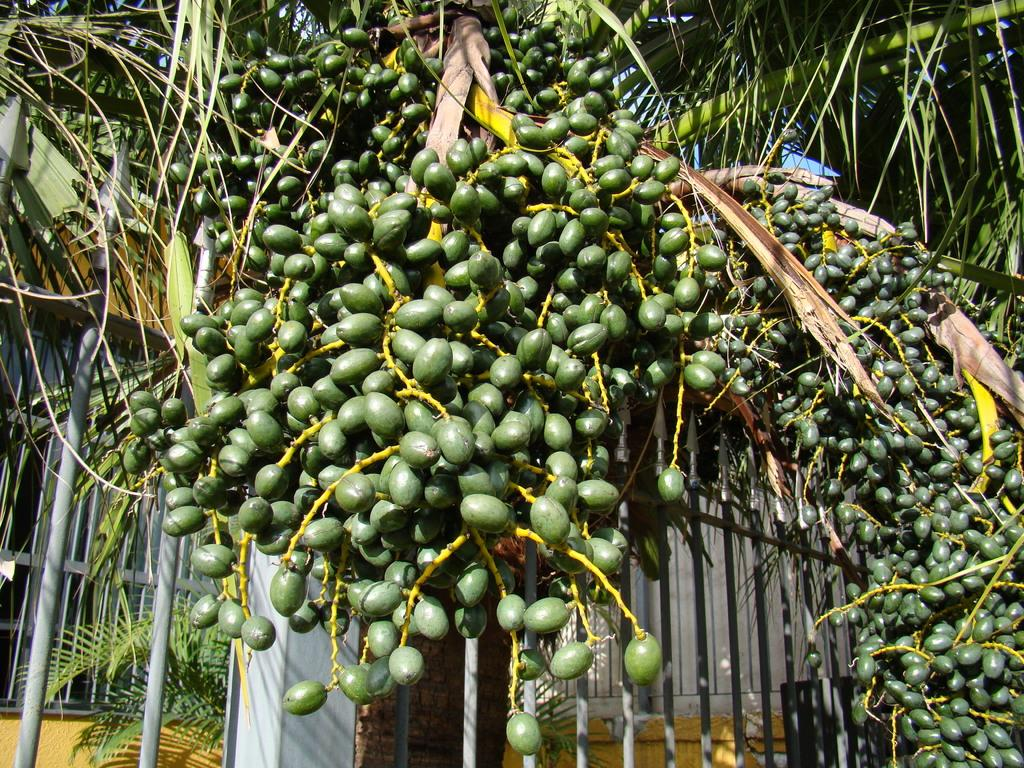What color can be observed on some objects in the image? There are green color objects in the image. What type of plant material is present in the image? There are leaves in the image. What type of structure can be seen in the image? There is a fence in the image. What type of amusement can be seen in the image? There is no amusement present in the image; it features green objects, leaves, and a fence. What force is being applied to the fence in the image? There is no force being applied to the fence in the image; it is stationary. 